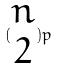Convert formula to latex. <formula><loc_0><loc_0><loc_500><loc_500>( \begin{matrix} n \\ 2 \end{matrix} ) p</formula> 